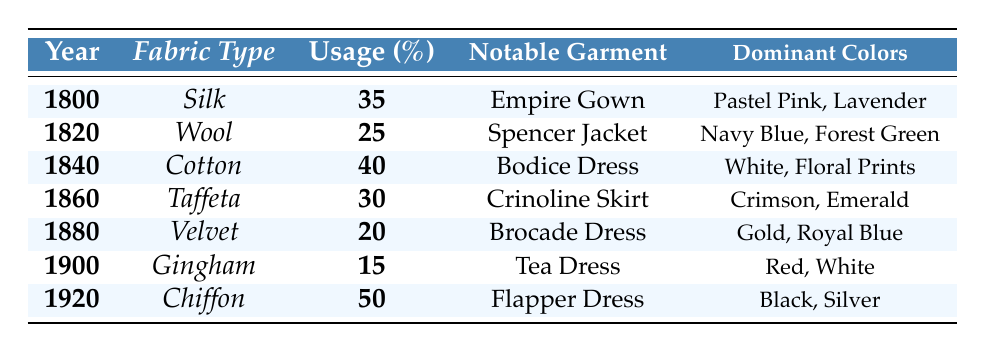What's the usage percentage of Silk in 1800? In the table, the row corresponding to the year 1800 shows that the fabric type is Silk with a usage percentage of 35.
Answer: 35 Which notable garment is associated with the year 1840? By looking at the entry for the year 1840 in the table, the notable garment listed is the Bodice Dress.
Answer: Bodice Dress What are the dominant colors for the Chiffon fabric used in 1920? In the table, under the year 1920, the dominant colors for Chiffon are listed as Black and Silver.
Answer: Black, Silver What is the average usage percentage of all fabric types from 1800 to 1920? To find the average, sum the usage percentages: (35 + 25 + 40 + 30 + 20 + 15 + 50) = 215. There are 7 entries, so the average is 215/7, which equals approximately 30.71.
Answer: 30.71 Is the usage percentage of Velvet greater than that of Gingham? Velvet has a usage percentage of 20 and Gingham has a usage percentage of 15. Since 20 is greater than 15, the answer is yes.
Answer: Yes In which year did Cotton fabric have the highest usage percentage? Cotton had a usage percentage of 40 in 1840. By checking other years, we can see that no other year has a higher usage percentage than 40.
Answer: 1840 What is the difference in usage percentage between the most used fabric in 1920 and the least used fabric in 1900? The most used fabric in 1920 is Chiffon with a usage percentage of 50, and the least used fabric in 1900 is Gingham with a percentage of 15. The difference is 50 - 15 = 35.
Answer: 35 List the notable garments used with Taffeta in 1860 and Velvet in 1880. In 1860, the notable garment associated with Taffeta is the Crinoline Skirt. In 1880, the notable garment associated with Velvet is the Brocade Dress.
Answer: Crinoline Skirt, Brocade Dress Did the usage percentage of fabrics increase or decrease from 1900 to 1920? In 1900, the usage percentage was 15 for Gingham, and in 1920 it was 50 for Chiffon. Since 50 is greater than 15, the usage percentage increased.
Answer: Increased 